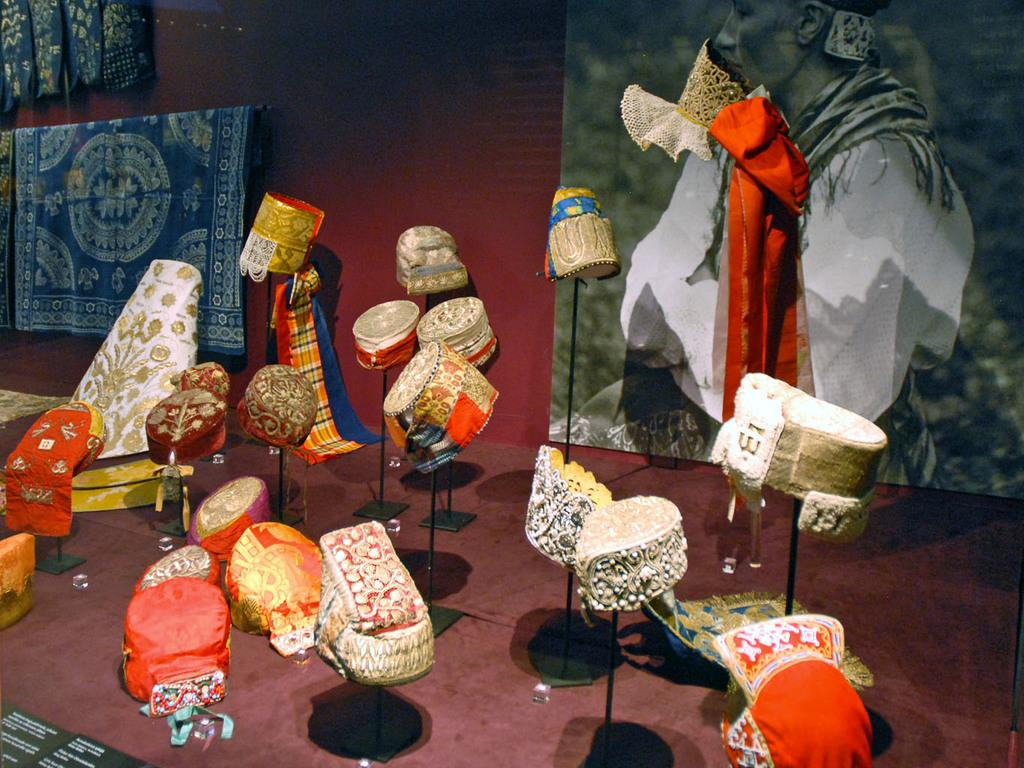What type of musical instrument is present in the image? There are musical drums in the image. What else can be seen in the image besides the drums? There are clothes and a red color wall visible in the image. What is hanging on the wall in the image? There is a banner in the image. What is depicted on the banner? The banner features a person wearing a red color dress. How many letters can be seen on the range in the image? There is no range present in the image, and therefore no letters can be seen on it. 